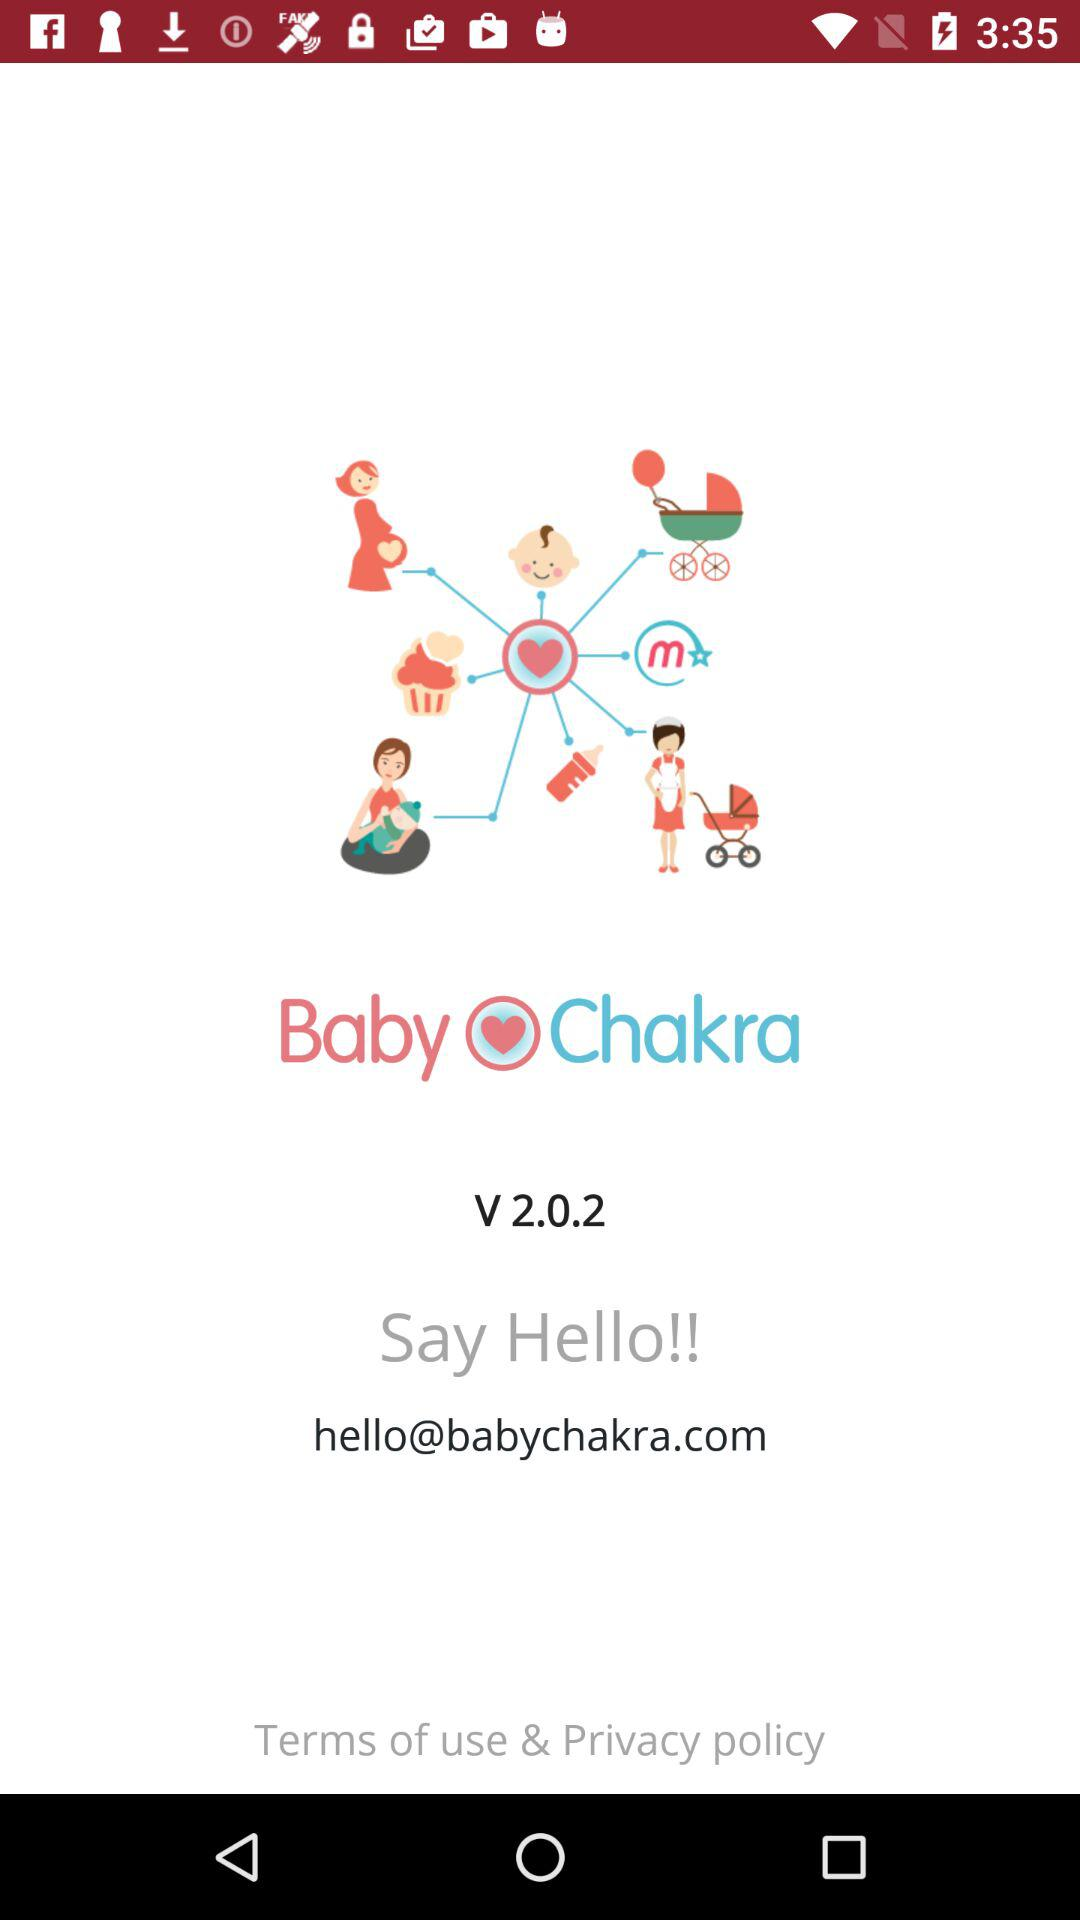What is the application version? The application version is 2.0.2. 